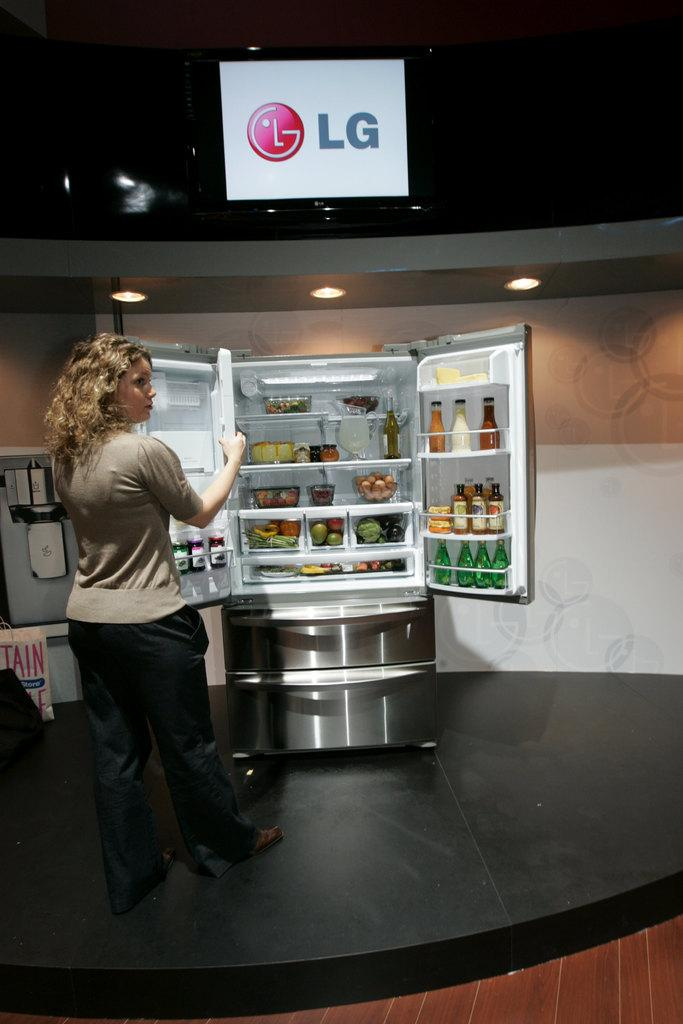<image>
Present a compact description of the photo's key features. A woman is in front of an opened refrigerator under the sign that says LG. 